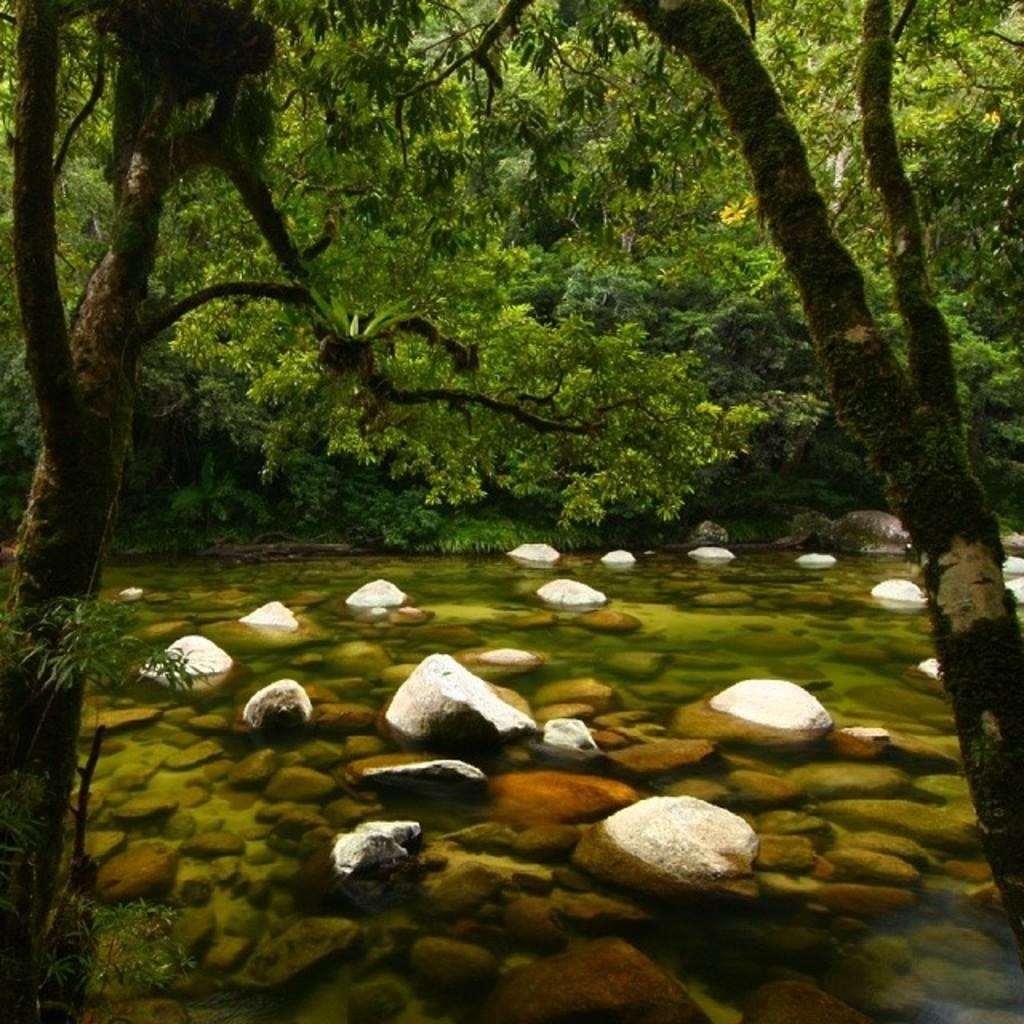What type of natural elements can be seen in the image? There are rocks, water, and trees visible in the image. Can you describe the water in the image? The water is visible in the image, but its specific characteristics are not mentioned. What type of vegetation is present in the image? Trees are present in the image. What type of texture can be seen on the giraffe's fur in the image? There is no giraffe present in the image; it features rocks, water, and trees. What type of party is being held in the image? There is no party depicted in the image; it features rocks, water, and trees. 